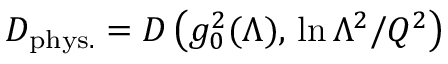<formula> <loc_0><loc_0><loc_500><loc_500>D _ { p h y s . } = D \left ( g _ { 0 } ^ { 2 } ( \Lambda ) , \, \ln \Lambda ^ { 2 } / Q ^ { 2 } \right )</formula> 